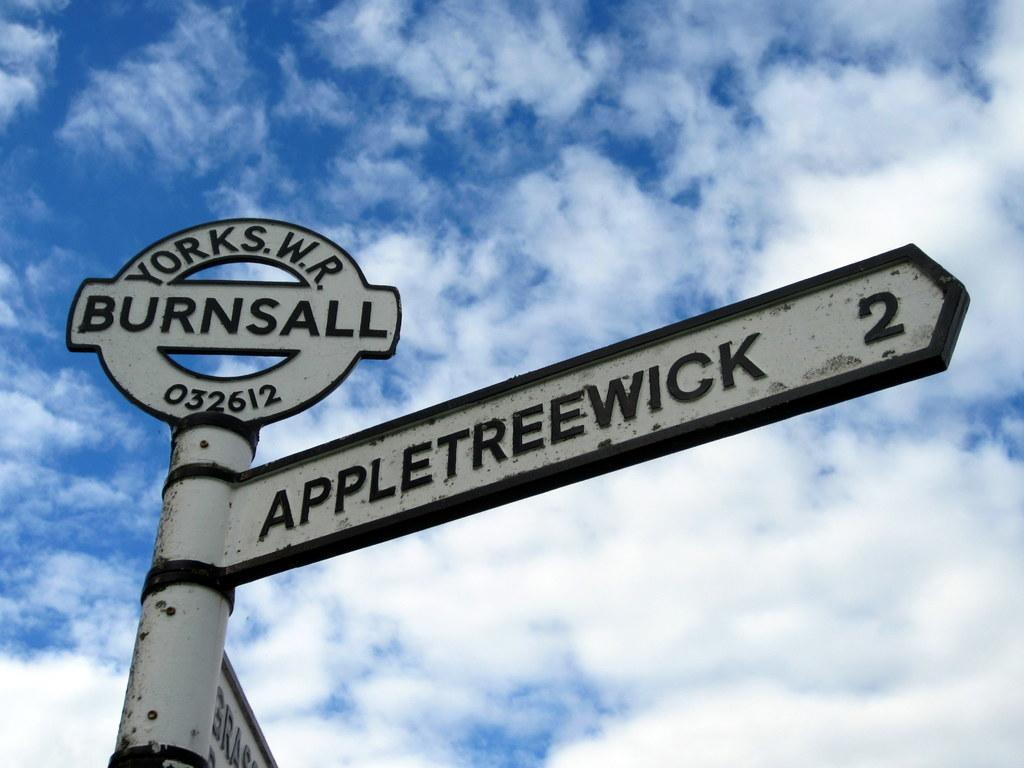<image>
Provide a brief description of the given image. An antique street sign in Burnsall featuring Appletreewick street. 